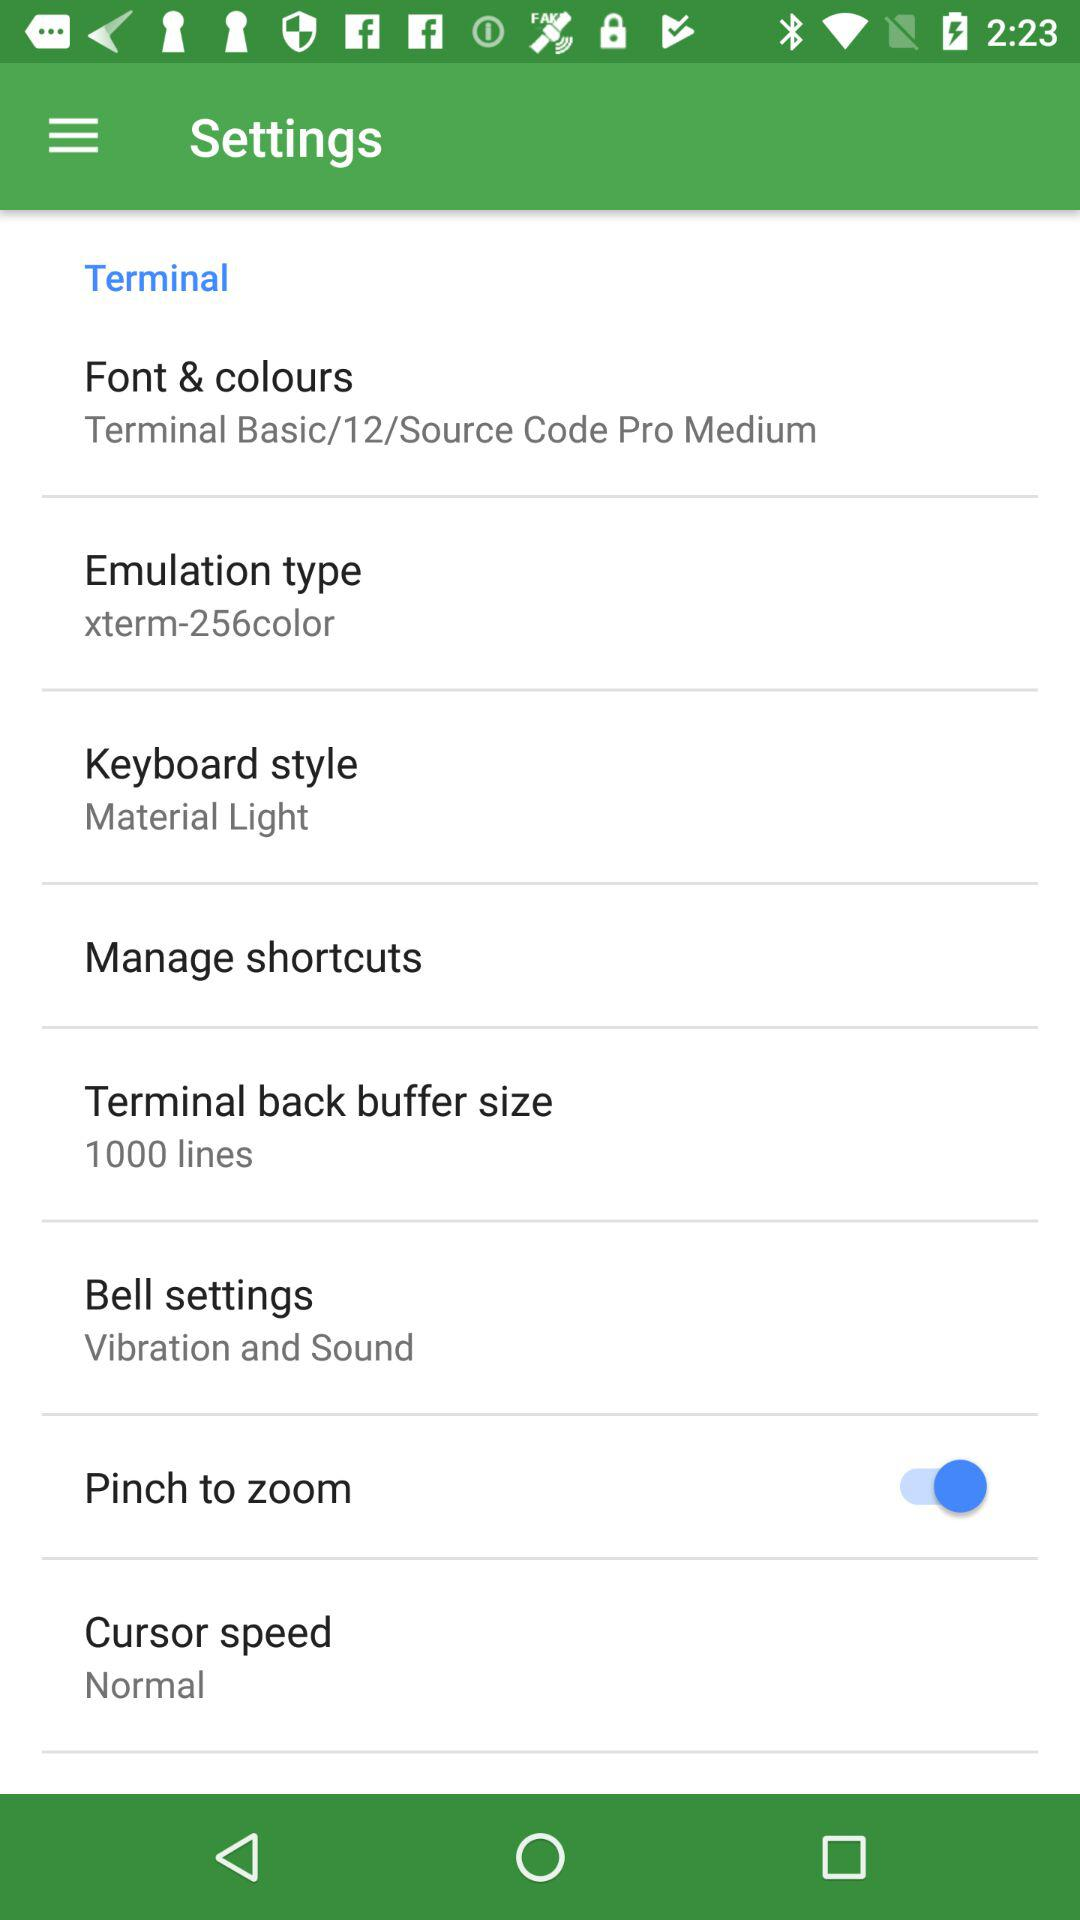What's the terminal back buffer size? The terminal back buffer size is "1000 lines". 